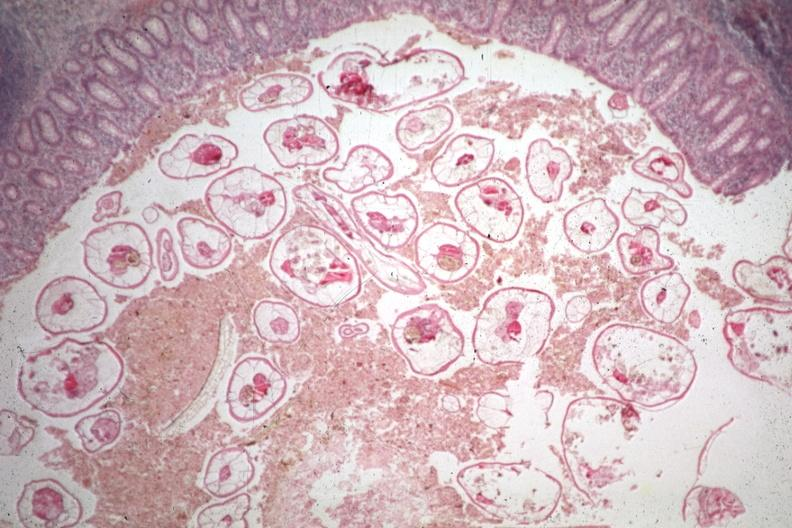s gastrointestinal present?
Answer the question using a single word or phrase. Yes 